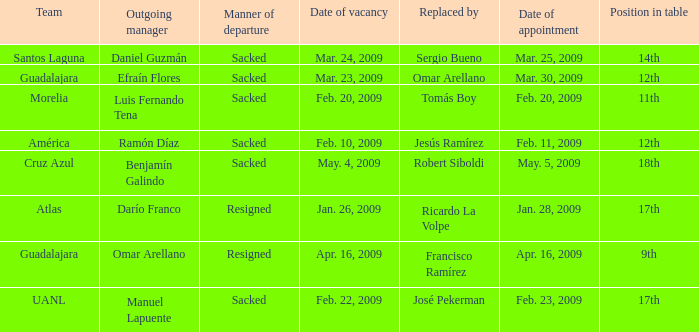What is Team, when Replaced By is "Omar Arellano"? Guadalajara. 